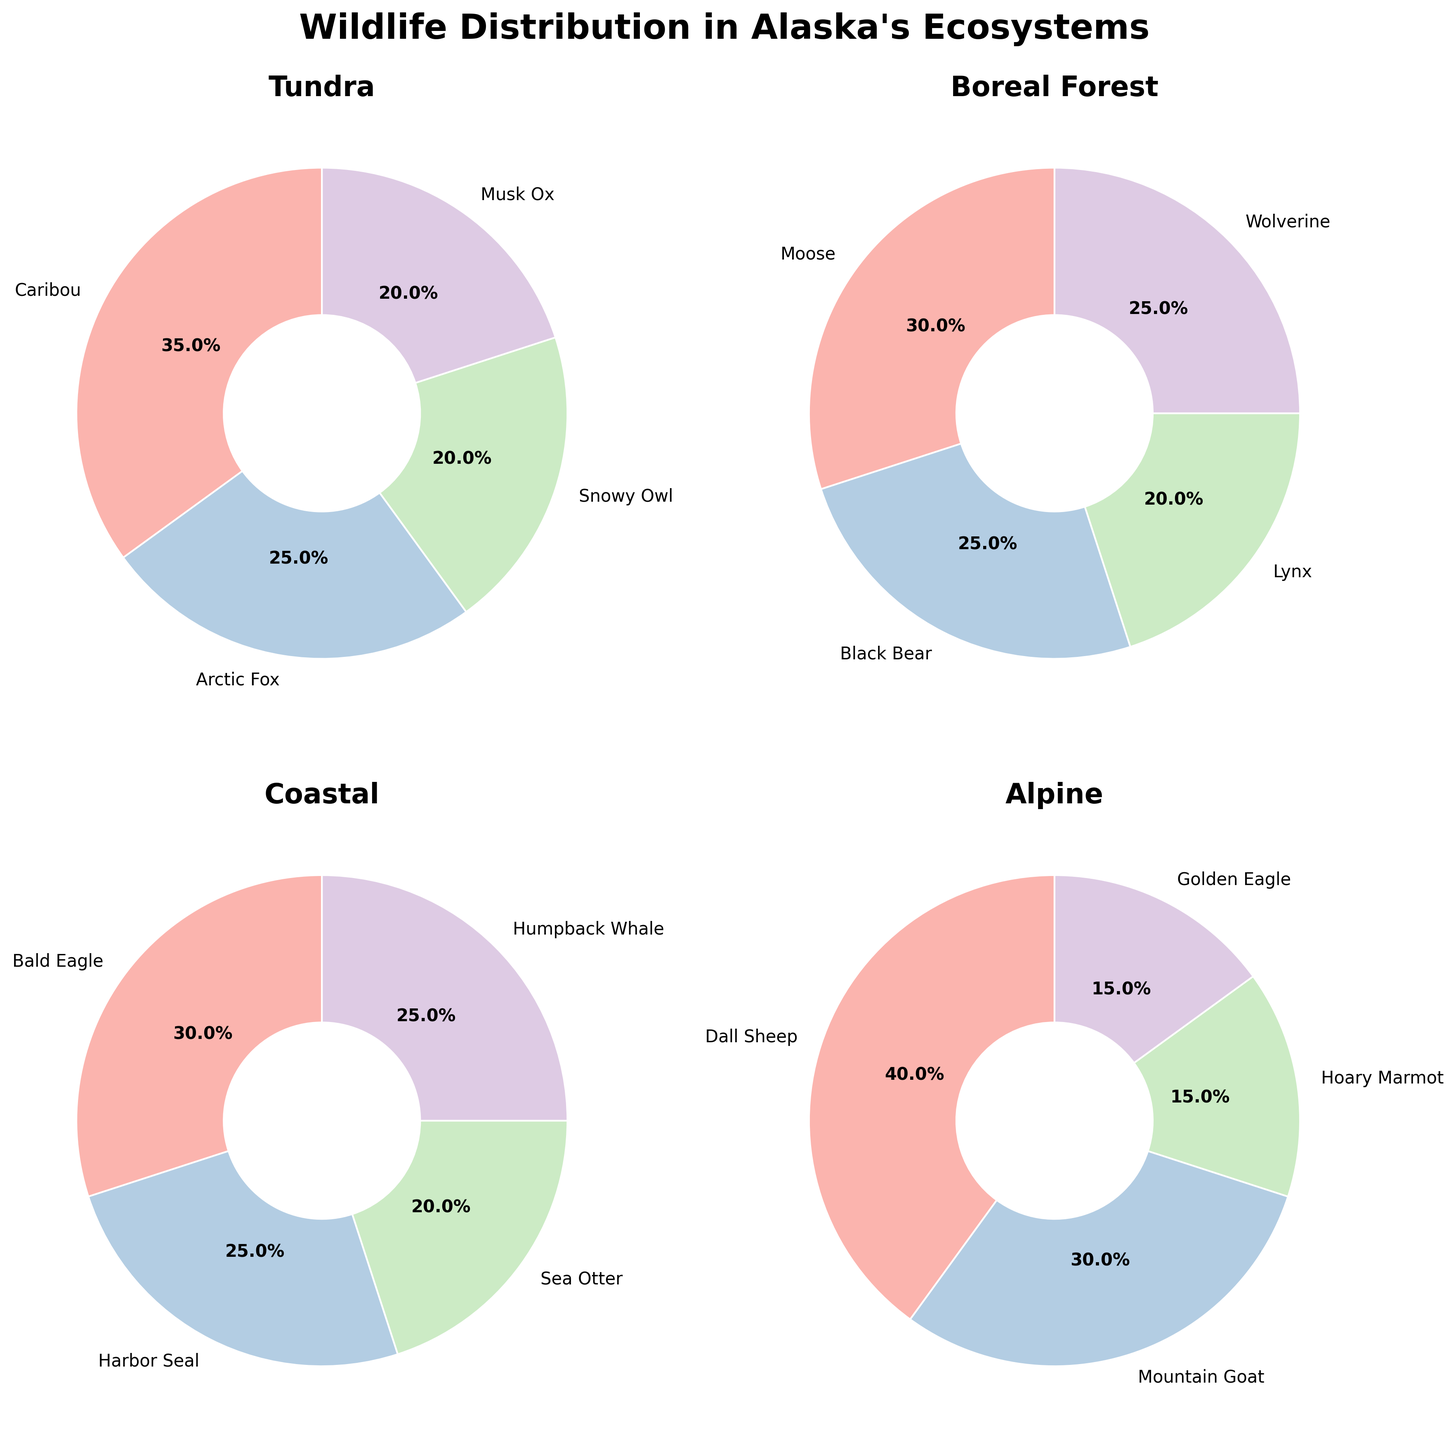What is the title of the subplot figure? The title of the subplot figure is generally found at the top center of the figure. It helps understand the overall theme of the visual data.
Answer: Wildlife Distribution in Alaska's Ecosystems Which species has the highest percentage in the Alpine ecosystem? Locate the pie chart labeled "Alpine" and identify the species with the largest segment. The Dall Sheep has the largest segment.
Answer: Dall Sheep Sum up the percentages of the species in the Tundra ecosystem. Add up the percentages given for each species in the pie chart labeled "Tundra". Specifically: 35% (Caribou) + 25% (Arctic Fox) + 20% (Snowy Owl) + 20% (Musk Ox) = 100%.
Answer: 100% Compare the percentage of Moose in the Boreal Forest to the percentage of Bald Eagle in the Coastal ecosystem. Which one is larger? Check the pie chart labeled "Boreal Forest" for Moose (30%) and the one labeled "Coastal" for Bald Eagle (30%). Since both values are identical – 30%, neither is larger.
Answer: Both are equal How many species are depicted in the pie chart for the Coastal ecosystem? Count the number of distinct segments (species labels) in the pie chart labeled "Coastal". There are four segments: Bald Eagle, Harbor Seal, Sea Otter, and Humpback Whale.
Answer: 4 What percentage of the total species in the Boreal Forest is occupied by the Black Bear and Wolverine together? Add the percentage of Black Bear (25%) and Wolverine (25%) from the pie chart labeled "Boreal Forest". Thus, 25% + 25% = 50%.
Answer: 50% Which ecosystem has the species with the largest single percentage share, and what is the species? Identify the largest single segment across all the pie charts. The Alpine ecosystem features Dall Sheep with a percentage of 40%, the largest single share.
Answer: Alpine, Dall Sheep Which ecosystem has the most evenly distributed species percentages? To identify the most evenly distributed ecosystem, look for a pie chart where the percentages differ the least between each species. The Tundra ecosystem, with 25%, 20%, 20%, and 35%, is reasonably even but not perfectly so. The Coastal ecosystem, with segments of 30%, 25%, 20%, and 25%, is more evenly distributed.
Answer: Coastal Is the percentage of Sea Otter in the Coastal ecosystem higher than the percentage of Mountain Goat in the Alpine ecosystem? Refer to both pie charts and compare the specific percentages for the Sea Otter (20%) and the Mountain Goat (30%). 20% is less than 30%.
Answer: No What is the combined percentage of species labeled Hoary Marmot and Golden Eagle in the Alpine ecosystem? Add the percentages of Hoary Marmot (15%) and Golden Eagle (15%) from the pie chart labeled "Alpine". Thus, 15% + 15% = 30%.
Answer: 30% 